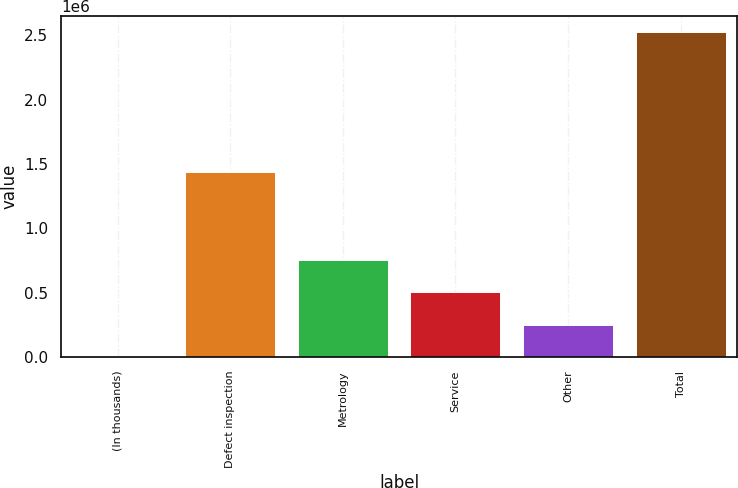<chart> <loc_0><loc_0><loc_500><loc_500><bar_chart><fcel>(In thousands)<fcel>Defect inspection<fcel>Metrology<fcel>Service<fcel>Other<fcel>Total<nl><fcel>2008<fcel>1.43428e+06<fcel>757920<fcel>505950<fcel>253979<fcel>2.52172e+06<nl></chart> 